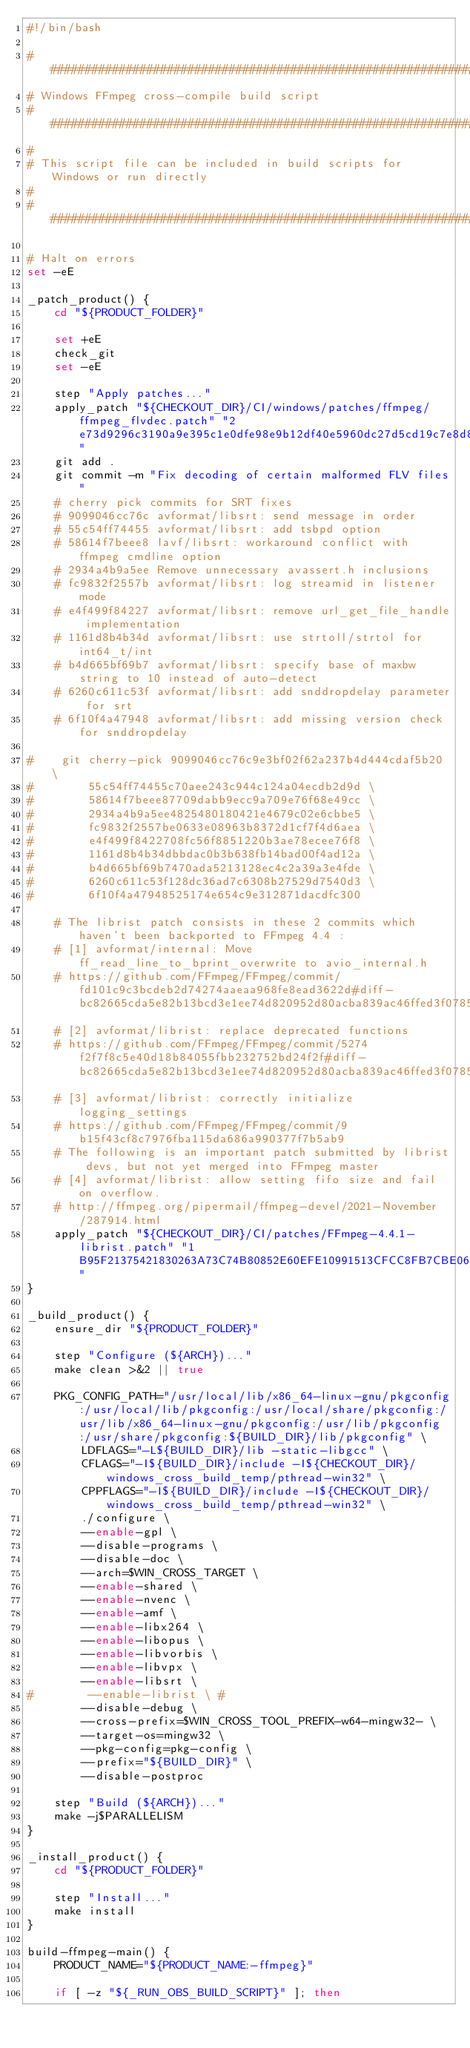Convert code to text. <code><loc_0><loc_0><loc_500><loc_500><_Bash_>#!/bin/bash

################################################################################
# Windows FFmpeg cross-compile build script
################################################################################
#
# This script file can be included in build scripts for Windows or run directly
#
################################################################################

# Halt on errors
set -eE

_patch_product() {
    cd "${PRODUCT_FOLDER}"

    set +eE
    check_git
    set -eE

    step "Apply patches..."
    apply_patch "${CHECKOUT_DIR}/CI/windows/patches/ffmpeg/ffmpeg_flvdec.patch" "2e73d9296c3190a9e395c1e0dfe98e9b12df40e5960dc27d5cd19c7e8d8695ab"
    git add .
    git commit -m "Fix decoding of certain malformed FLV files"
    # cherry pick commits for SRT fixes
    # 9099046cc76c avformat/libsrt: send message in order
    # 55c54ff74455 avformat/libsrt: add tsbpd option
    # 58614f7beee8 lavf/libsrt: workaround conflict with ffmpeg cmdline option
    # 2934a4b9a5ee Remove unnecessary avassert.h inclusions
    # fc9832f2557b avformat/libsrt: log streamid in listener mode
    # e4f499f84227 avformat/libsrt: remove url_get_file_handle implementation
    # 1161d8b4b34d avformat/libsrt: use strtoll/strtol for int64_t/int 
    # b4d665bf69b7 avformat/libsrt: specify base of maxbw string to 10 instead of auto-detect
    # 6260c611c53f avformat/libsrt: add snddropdelay parameter for srt
    # 6f10f4a47948 avformat/libsrt: add missing version check for snddropdelay

#    git cherry-pick 9099046cc76c9e3bf02f62a237b4d444cdaf5b20 \
#        55c54ff74455c70aee243c944c124a04ecdb2d9d \
#        58614f7beee87709dabb9ecc9a709e76f68e49cc \
#        2934a4b9a5ee4825480180421e4679c02e6cbbe5 \
#        fc9832f2557be0633e08963b8372d1cf7f4d6aea \
#        e4f499f8422708fc56f8851220b3ae78ecee76f8 \
#        1161d8b4b34dbbdac0b3b638fb14bad00f4ad12a \
#        b4d665bf69b7470ada5213128ec4c2a39a3e4fde \
#        6260c611c53f128dc36ad7c6308b27529d7540d3 \
#        6f10f4a47948525174e654c9e312871dacdfc300

    # The librist patch consists in these 2 commits which haven't been backported to FFmpeg 4.4 :
    # [1] avformat/internal: Move ff_read_line_to_bprint_overwrite to avio_internal.h
    # https://github.com/FFmpeg/FFmpeg/commit/fd101c9c3bcdeb2d74274aaeaa968fe8ead3622d#diff-bc82665cda5e82b13bcd3e1ee74d820952d80acba839ac46ffed3f0785644200
    # [2] avformat/librist: replace deprecated functions
    # https://github.com/FFmpeg/FFmpeg/commit/5274f2f7f8c5e40d18b84055fbb232752bd24f2f#diff-bc82665cda5e82b13bcd3e1ee74d820952d80acba839ac46ffed3f0785644200
    # [3] avformat/librist: correctly initialize logging_settings
    # https://github.com/FFmpeg/FFmpeg/commit/9b15f43cf8c7976fba115da686a990377f7b5ab9
    # The following is an important patch submitted by librist devs, but not yet merged into FFmpeg master
    # [4] avformat/librist: allow setting fifo size and fail on overflow.
    # http://ffmpeg.org/pipermail/ffmpeg-devel/2021-November/287914.html
    apply_patch "${CHECKOUT_DIR}/CI/patches/FFmpeg-4.4.1-librist.patch" "1B95F21375421830263A73C74B80852E60EFE10991513CFCC8FB7CBE066887F5"
}

_build_product() {
    ensure_dir "${PRODUCT_FOLDER}"

    step "Configure (${ARCH})..."
    make clean >&2 || true

    PKG_CONFIG_PATH="/usr/local/lib/x86_64-linux-gnu/pkgconfig:/usr/local/lib/pkgconfig:/usr/local/share/pkgconfig:/usr/lib/x86_64-linux-gnu/pkgconfig:/usr/lib/pkgconfig:/usr/share/pkgconfig:${BUILD_DIR}/lib/pkgconfig" \
        LDFLAGS="-L${BUILD_DIR}/lib -static-libgcc" \
        CFLAGS="-I${BUILD_DIR}/include -I${CHECKOUT_DIR}/windows_cross_build_temp/pthread-win32" \
        CPPFLAGS="-I${BUILD_DIR}/include -I${CHECKOUT_DIR}/windows_cross_build_temp/pthread-win32" \
        ./configure \
        --enable-gpl \
        --disable-programs \
        --disable-doc \
        --arch=$WIN_CROSS_TARGET \
        --enable-shared \
        --enable-nvenc \
        --enable-amf \
        --enable-libx264 \
        --enable-libopus \
        --enable-libvorbis \
        --enable-libvpx \
        --enable-libsrt \
#        --enable-librist \ #
        --disable-debug \
        --cross-prefix=$WIN_CROSS_TOOL_PREFIX-w64-mingw32- \
        --target-os=mingw32 \
        --pkg-config=pkg-config \
        --prefix="${BUILD_DIR}" \
        --disable-postproc

    step "Build (${ARCH})..."
    make -j$PARALLELISM
}

_install_product() {
    cd "${PRODUCT_FOLDER}"

    step "Install..."
    make install
}

build-ffmpeg-main() {
    PRODUCT_NAME="${PRODUCT_NAME:-ffmpeg}"

    if [ -z "${_RUN_OBS_BUILD_SCRIPT}" ]; then</code> 